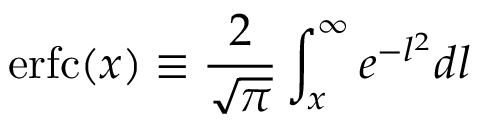Convert formula to latex. <formula><loc_0><loc_0><loc_500><loc_500>e r f c ( x ) \equiv \frac { 2 } { \sqrt { \pi } } \int _ { x } ^ { \infty } e ^ { - l ^ { 2 } } d l</formula> 